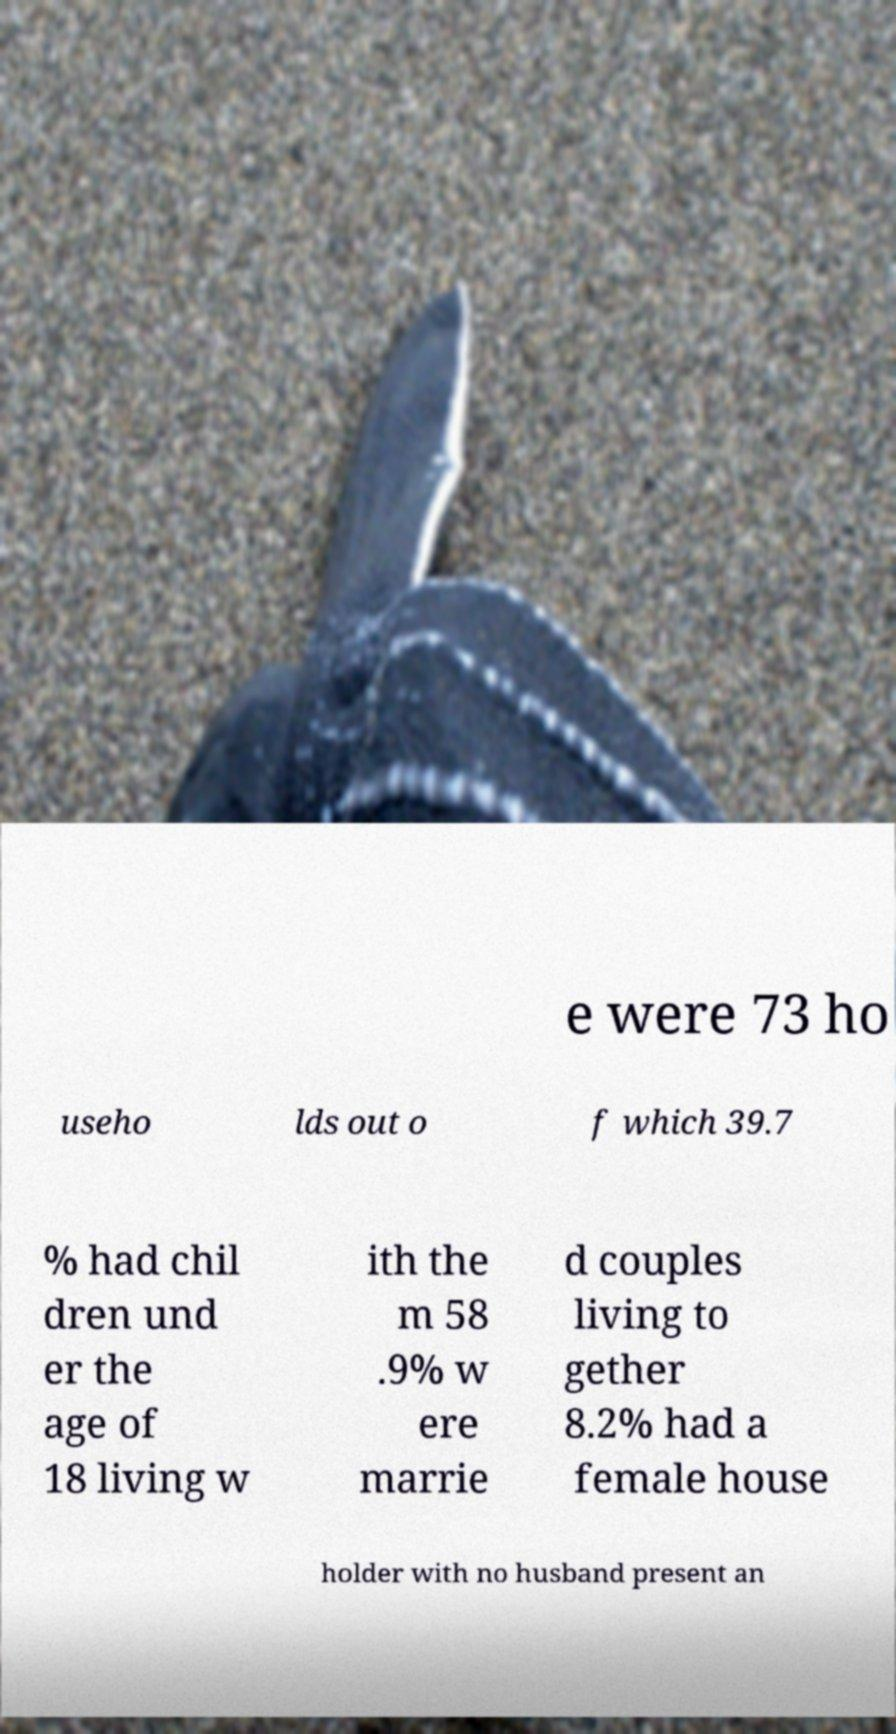Can you accurately transcribe the text from the provided image for me? e were 73 ho useho lds out o f which 39.7 % had chil dren und er the age of 18 living w ith the m 58 .9% w ere marrie d couples living to gether 8.2% had a female house holder with no husband present an 